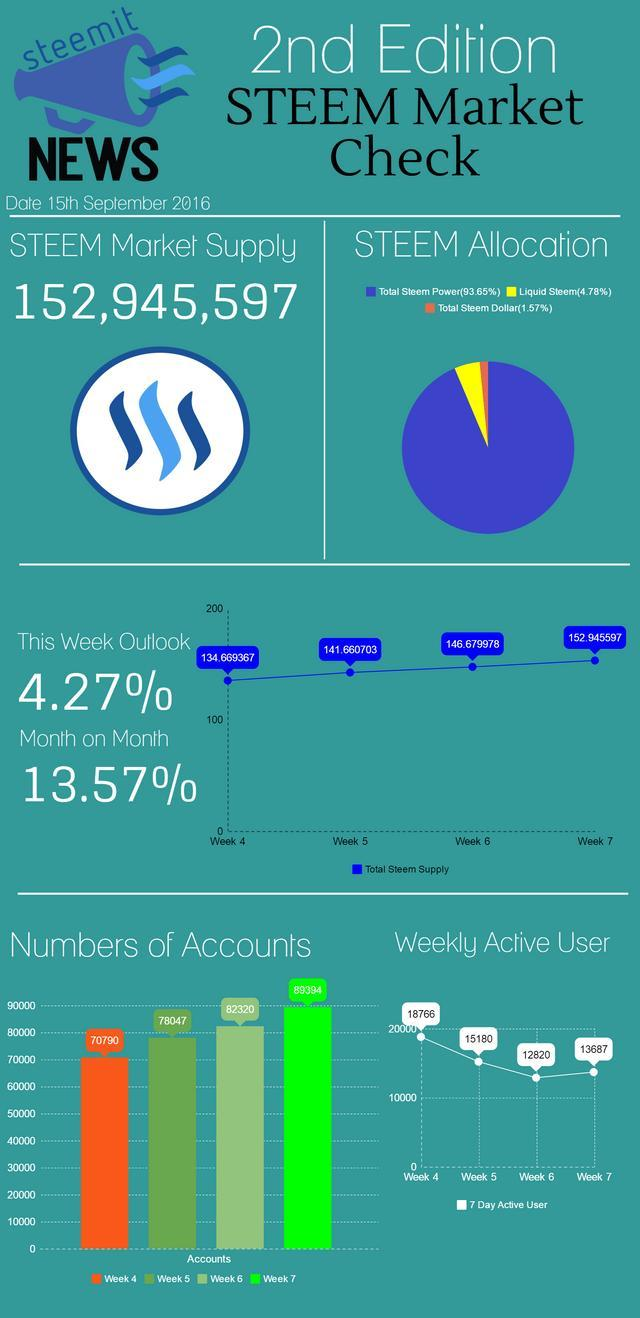Which has the highest share-total steem dollar, total steem power?
Answer the question with a short phrase. total steem power What is the total number of accounts in week 4 and week 5? 148837 